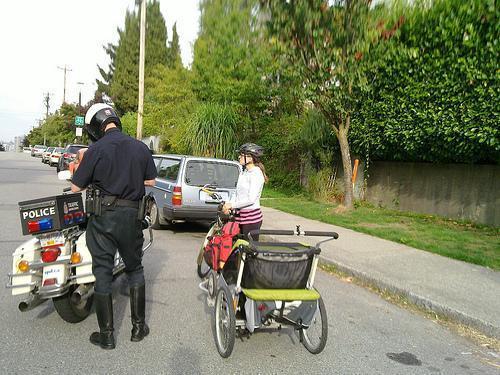How many people are in the photo?
Give a very brief answer. 2. 